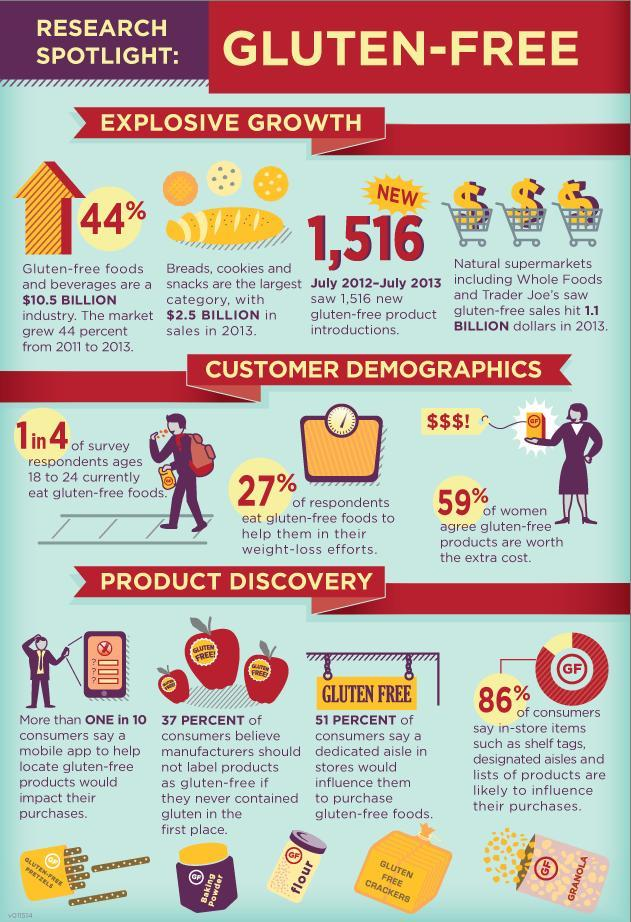What percent of women disagree with the fact that gluten-free products are worth the extra cost?
Answer the question with a short phrase. 41% 